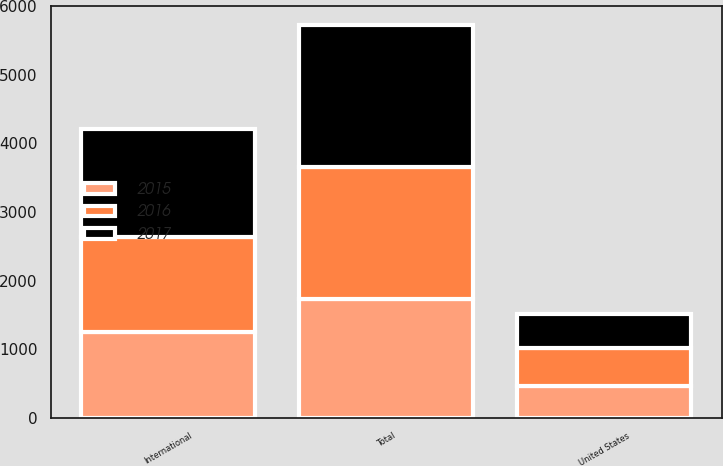Convert chart. <chart><loc_0><loc_0><loc_500><loc_500><stacked_bar_chart><ecel><fcel>United States<fcel>International<fcel>Total<nl><fcel>2017<fcel>499<fcel>1564<fcel>2063<nl><fcel>2016<fcel>542<fcel>1379<fcel>1921<nl><fcel>2015<fcel>475<fcel>1260<fcel>1735<nl></chart> 